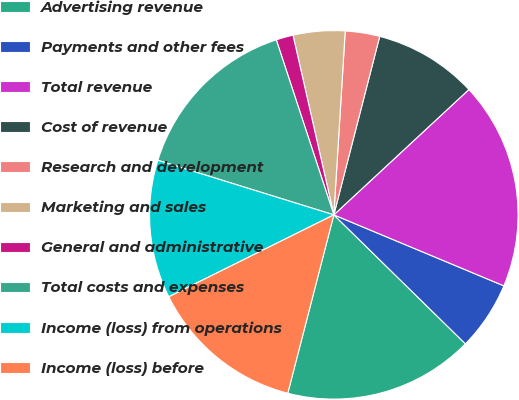Convert chart. <chart><loc_0><loc_0><loc_500><loc_500><pie_chart><fcel>Advertising revenue<fcel>Payments and other fees<fcel>Total revenue<fcel>Cost of revenue<fcel>Research and development<fcel>Marketing and sales<fcel>General and administrative<fcel>Total costs and expenses<fcel>Income (loss) from operations<fcel>Income (loss) before<nl><fcel>16.68%<fcel>6.05%<fcel>18.2%<fcel>9.09%<fcel>3.02%<fcel>4.54%<fcel>1.5%<fcel>15.16%<fcel>12.12%<fcel>13.64%<nl></chart> 